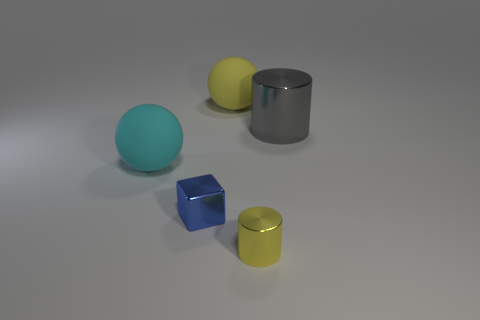Add 1 large cylinders. How many objects exist? 6 Subtract all balls. How many objects are left? 3 Subtract 0 green cubes. How many objects are left? 5 Subtract all large gray metallic cylinders. Subtract all large cyan matte spheres. How many objects are left? 3 Add 1 big cyan things. How many big cyan things are left? 2 Add 3 gray metallic blocks. How many gray metallic blocks exist? 3 